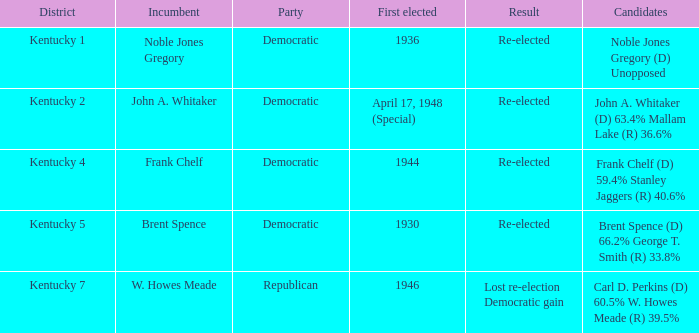Who were the candidates in the Kentucky 4 voting district? Frank Chelf (D) 59.4% Stanley Jaggers (R) 40.6%. 